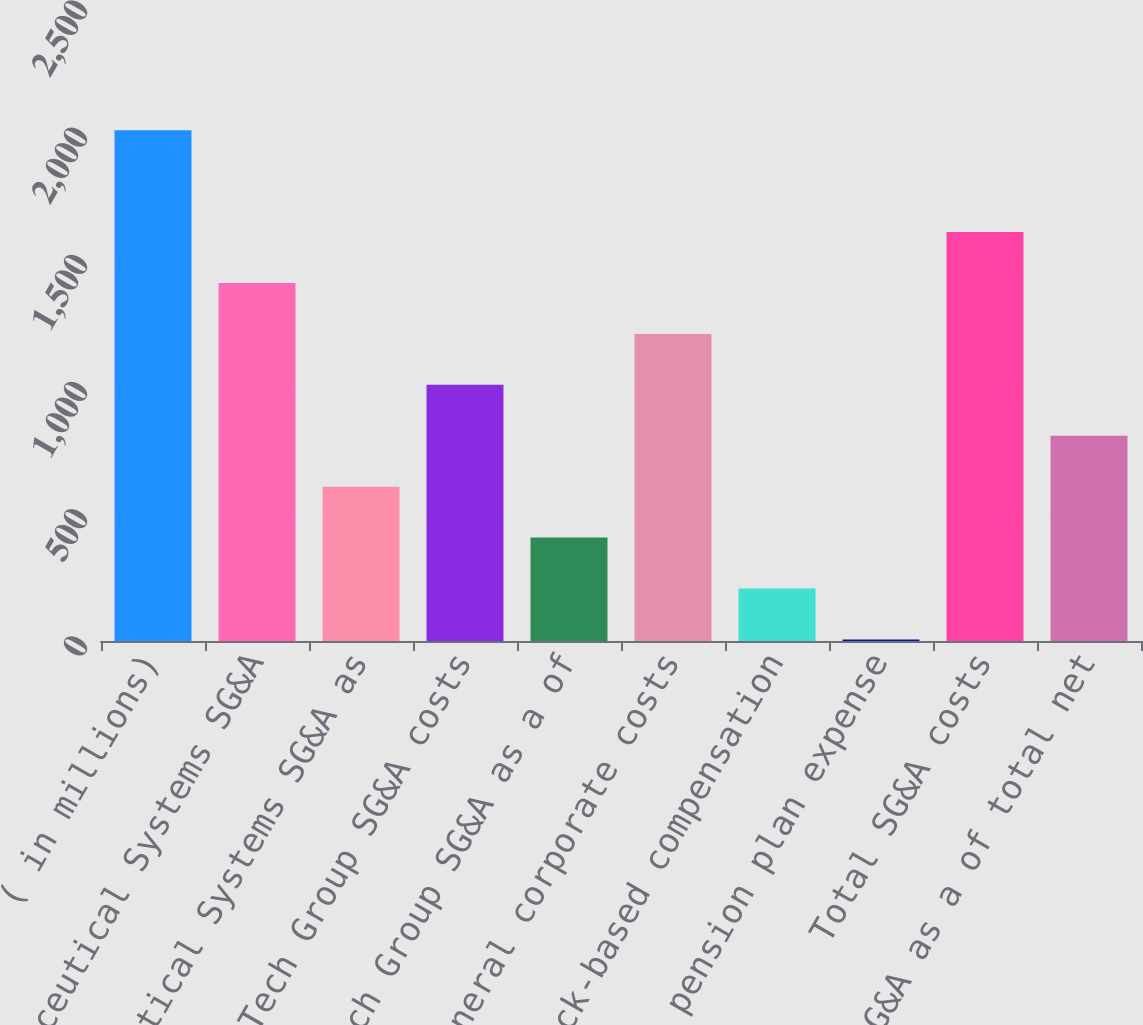Convert chart. <chart><loc_0><loc_0><loc_500><loc_500><bar_chart><fcel>( in millions)<fcel>Pharmaceutical Systems SG&A<fcel>Pharmaceutical Systems SG&A as<fcel>Tech Group SG&A costs<fcel>Tech Group SG&A as a of<fcel>General corporate costs<fcel>Stock-based compensation<fcel>US pension plan expense<fcel>Total SG&A costs<fcel>Total SG&A as a of total net<nl><fcel>2008<fcel>1407.4<fcel>606.6<fcel>1007<fcel>406.4<fcel>1207.2<fcel>206.2<fcel>6<fcel>1607.6<fcel>806.8<nl></chart> 